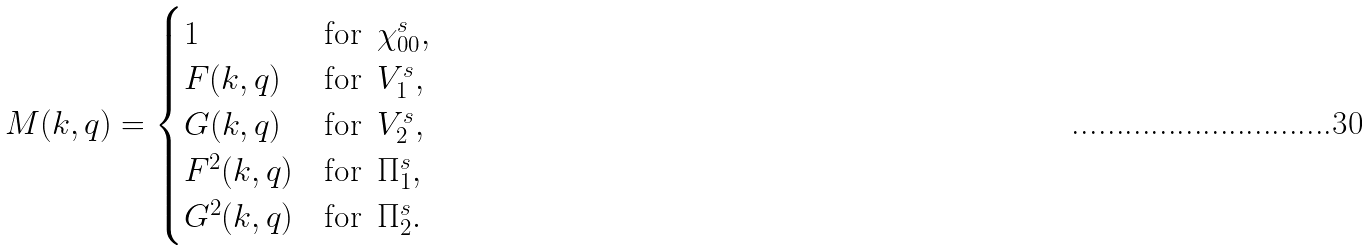Convert formula to latex. <formula><loc_0><loc_0><loc_500><loc_500>M ( k , q ) = \begin{cases} 1 & \text {for \,$\chi^{s}_{00}$} , \\ F ( k , q ) & \text {for \,$V^{s}_{1}$} , \\ G ( k , q ) & \text {for \,$V^{s}_{2}$} , \\ F ^ { 2 } ( k , q ) & \text {for \,$\Pi^{s}_{1}$} , \\ G ^ { 2 } ( k , q ) & \text {for \,$\Pi^{s}_{2}$} . \end{cases}</formula> 